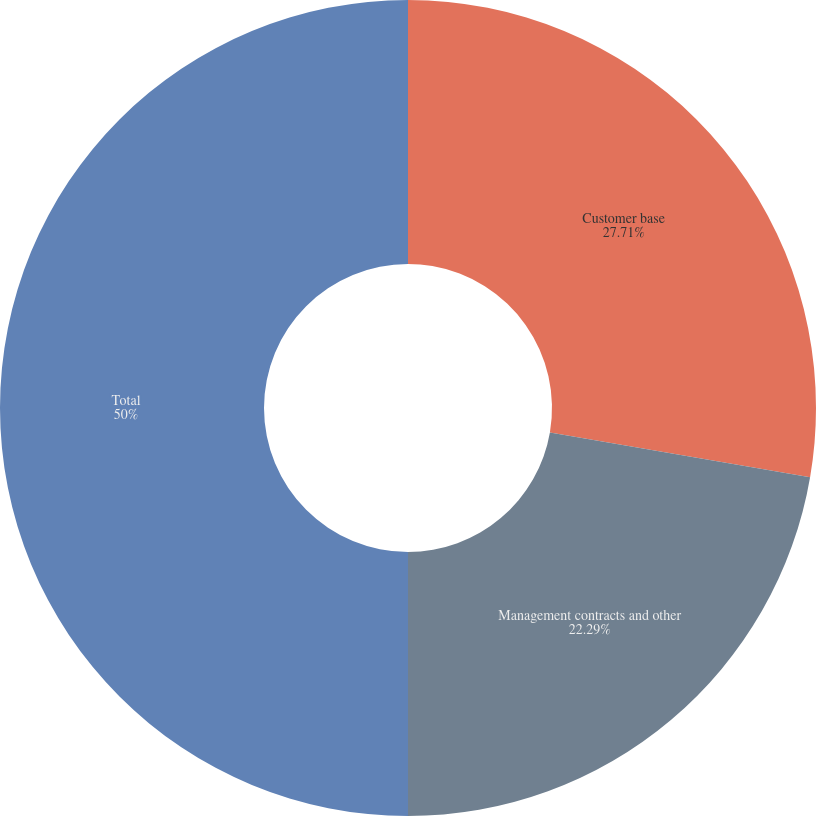Convert chart to OTSL. <chart><loc_0><loc_0><loc_500><loc_500><pie_chart><fcel>Customer base<fcel>Management contracts and other<fcel>Total<nl><fcel>27.71%<fcel>22.29%<fcel>50.0%<nl></chart> 